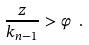Convert formula to latex. <formula><loc_0><loc_0><loc_500><loc_500>\frac { z } { k _ { n - 1 } } > \varphi \ .</formula> 